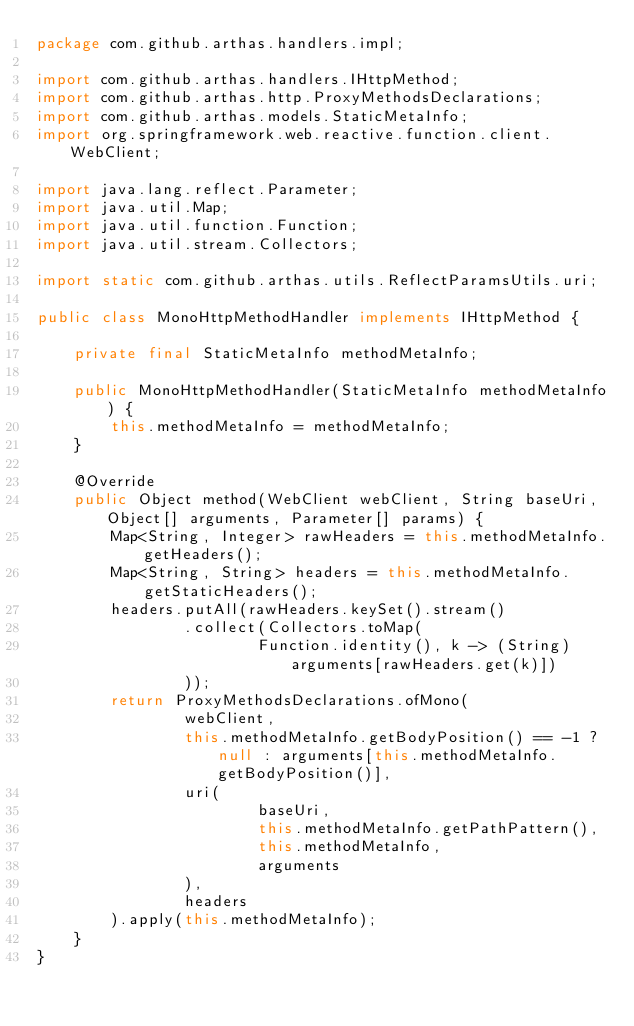Convert code to text. <code><loc_0><loc_0><loc_500><loc_500><_Java_>package com.github.arthas.handlers.impl;

import com.github.arthas.handlers.IHttpMethod;
import com.github.arthas.http.ProxyMethodsDeclarations;
import com.github.arthas.models.StaticMetaInfo;
import org.springframework.web.reactive.function.client.WebClient;

import java.lang.reflect.Parameter;
import java.util.Map;
import java.util.function.Function;
import java.util.stream.Collectors;

import static com.github.arthas.utils.ReflectParamsUtils.uri;

public class MonoHttpMethodHandler implements IHttpMethod {

    private final StaticMetaInfo methodMetaInfo;

    public MonoHttpMethodHandler(StaticMetaInfo methodMetaInfo) {
        this.methodMetaInfo = methodMetaInfo;
    }

    @Override
    public Object method(WebClient webClient, String baseUri, Object[] arguments, Parameter[] params) {
        Map<String, Integer> rawHeaders = this.methodMetaInfo.getHeaders();
        Map<String, String> headers = this.methodMetaInfo.getStaticHeaders();
        headers.putAll(rawHeaders.keySet().stream()
                .collect(Collectors.toMap(
                        Function.identity(), k -> (String) arguments[rawHeaders.get(k)])
                ));
        return ProxyMethodsDeclarations.ofMono(
                webClient,
                this.methodMetaInfo.getBodyPosition() == -1 ? null : arguments[this.methodMetaInfo.getBodyPosition()],
                uri(
                        baseUri,
                        this.methodMetaInfo.getPathPattern(),
                        this.methodMetaInfo,
                        arguments
                ),
                headers
        ).apply(this.methodMetaInfo);
    }
}
</code> 